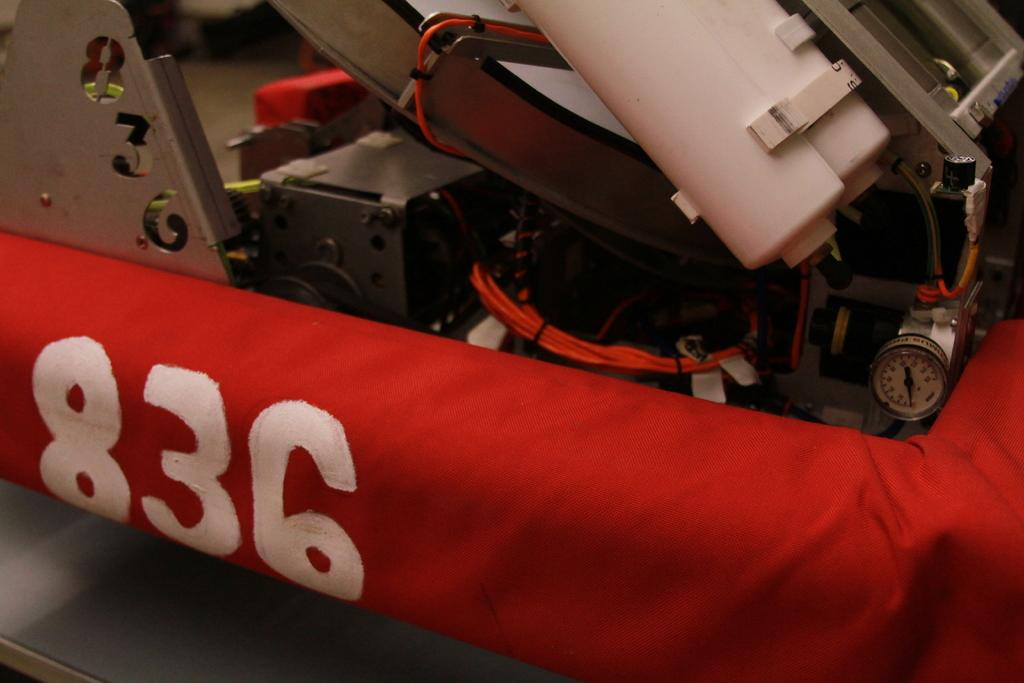What type of equipment is shown in the image? There is a machine tool in the image. What is placed under the machine tool? There is a red cloth under the machine tool. Are there any markings or symbols on the red cloth? Yes, there are numbers visible on the red cloth. What is the surface on which the machine tool and red cloth are placed? There is a table at the bottom of the image. What type of gate is visible in the image? There is no gate present in the image; it features a machine tool, a red cloth, and a table. 